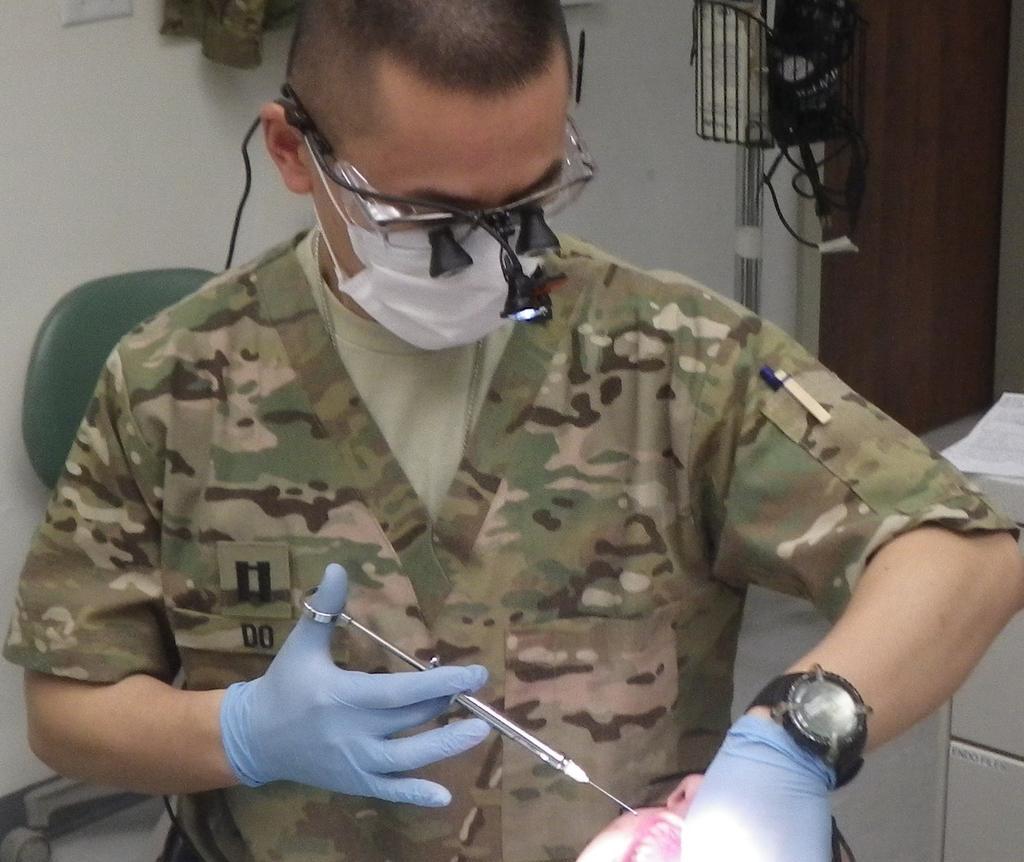How would you summarize this image in a sentence or two? In this image we can see a person holding a syringe, he is wearing specs, there are some objects on the stand, there is a chair, there are papers on the desk, also we can see the head of a person, and the wall. 